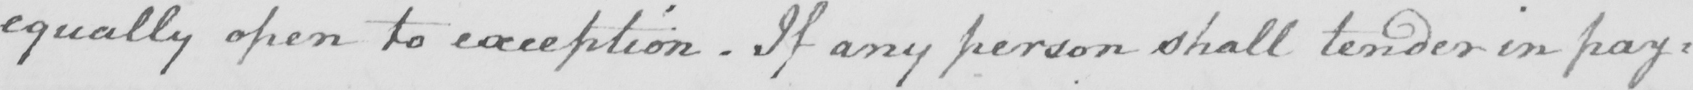Can you read and transcribe this handwriting? equally open to exception  . If any person shall tender in pay= 